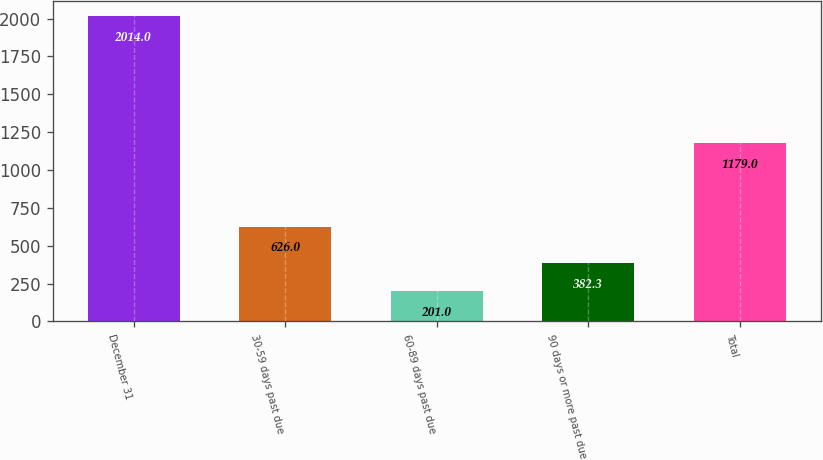Convert chart to OTSL. <chart><loc_0><loc_0><loc_500><loc_500><bar_chart><fcel>December 31<fcel>30-59 days past due<fcel>60-89 days past due<fcel>90 days or more past due<fcel>Total<nl><fcel>2014<fcel>626<fcel>201<fcel>382.3<fcel>1179<nl></chart> 